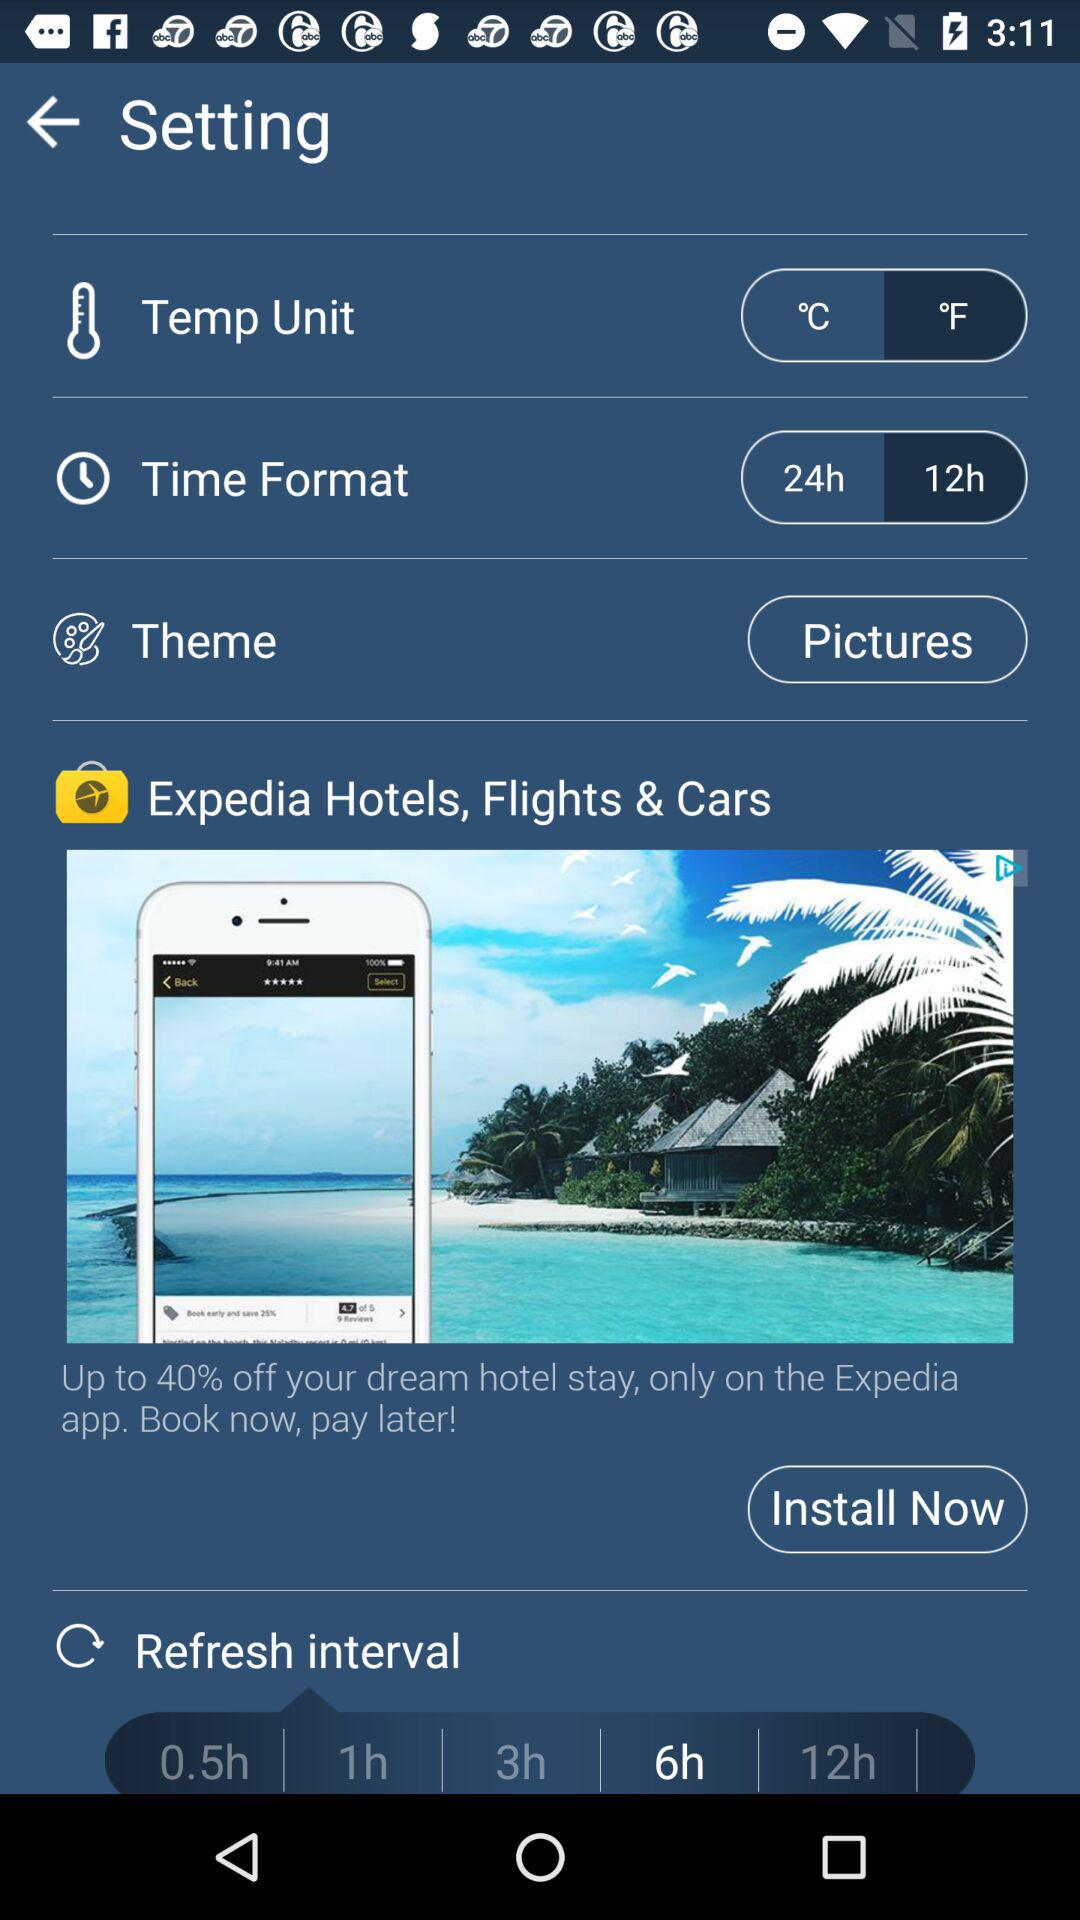What is the refresh interval time? The refresh interval time is 6 hours. 